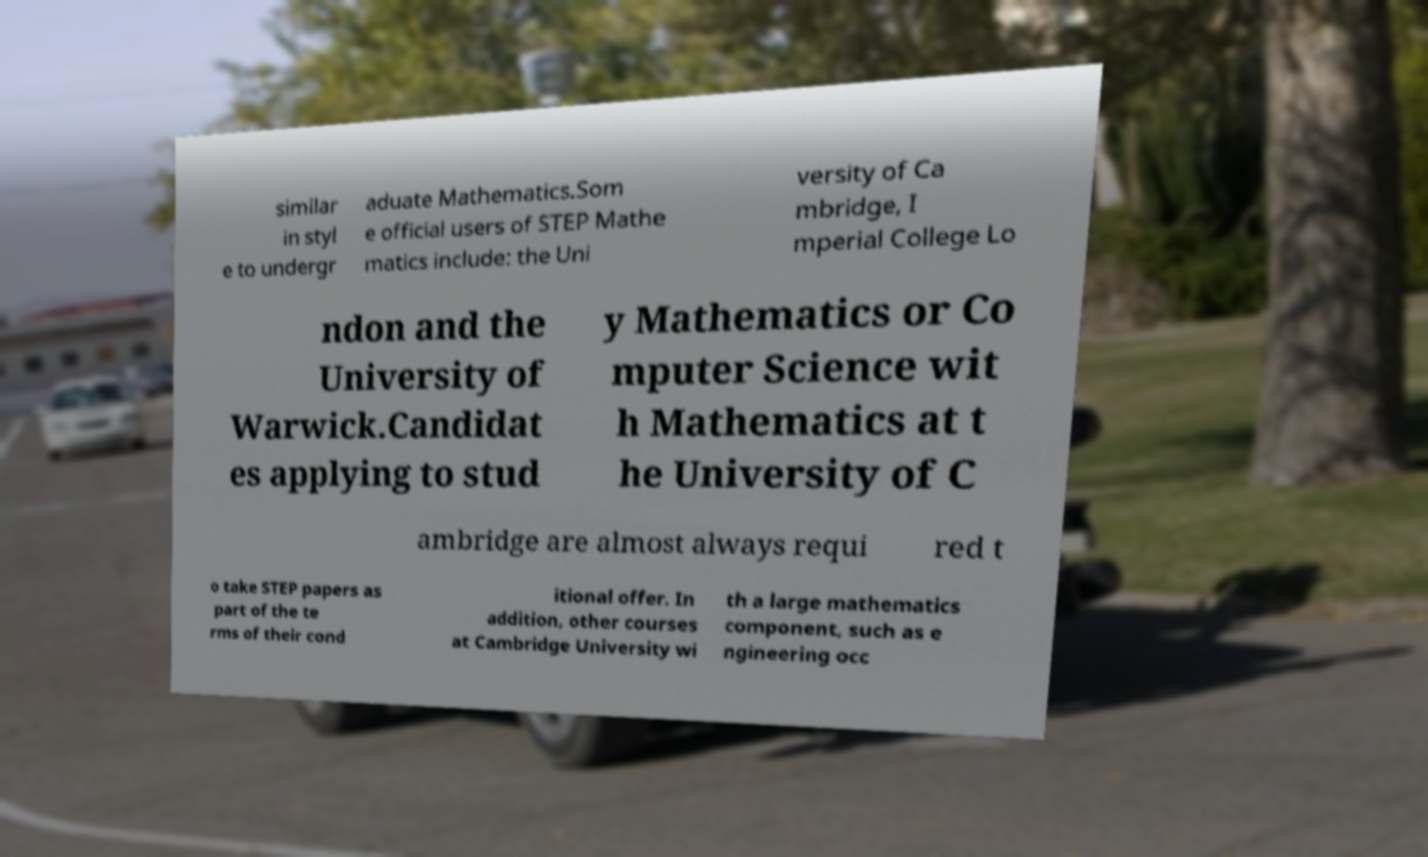Could you extract and type out the text from this image? similar in styl e to undergr aduate Mathematics.Som e official users of STEP Mathe matics include: the Uni versity of Ca mbridge, I mperial College Lo ndon and the University of Warwick.Candidat es applying to stud y Mathematics or Co mputer Science wit h Mathematics at t he University of C ambridge are almost always requi red t o take STEP papers as part of the te rms of their cond itional offer. In addition, other courses at Cambridge University wi th a large mathematics component, such as e ngineering occ 